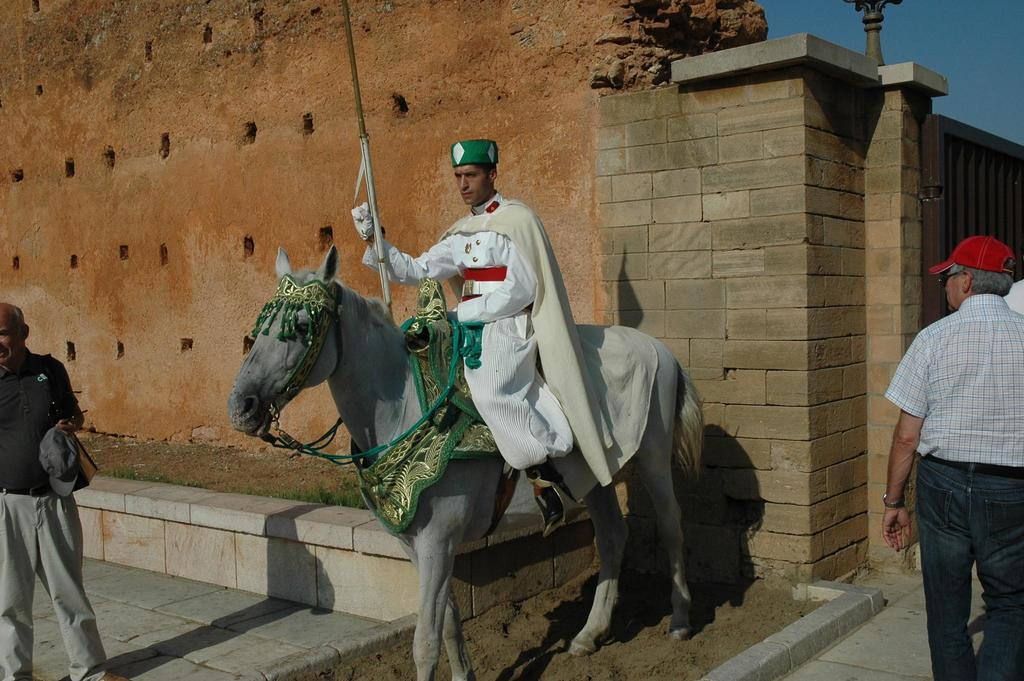What is the man in the image doing? The man is sitting on a horse. What is the surface beneath the man and the horse? There is a floor in the image. How many people are present in the image? There are two persons in the image. What can be seen in the background of the image? There is a wall and the sky visible in the background of the image. How many rings does the pot in the image have? There is no pot present in the image, so it is not possible to determine the number of rings it might have. 